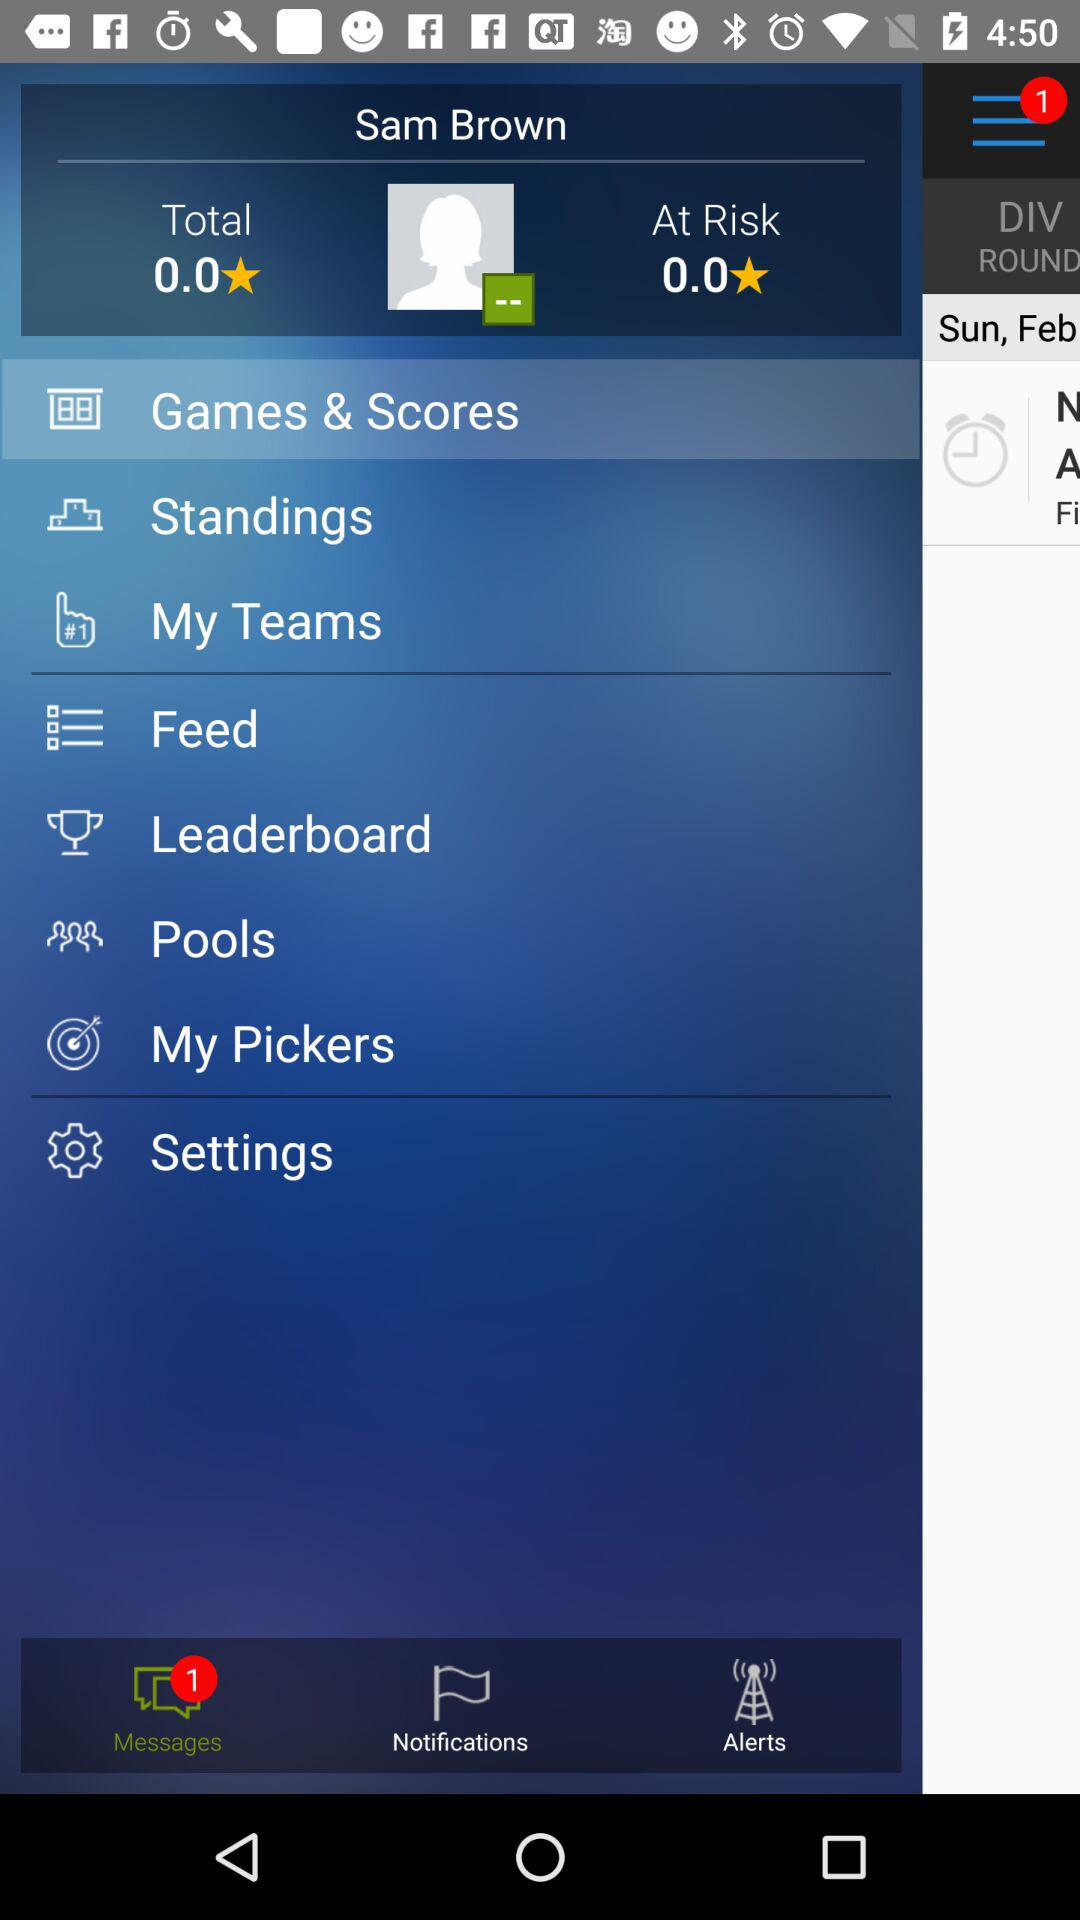What is the difference in value between the total and at risk amounts?
Answer the question using a single word or phrase. 0.0 